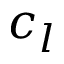Convert formula to latex. <formula><loc_0><loc_0><loc_500><loc_500>c _ { l }</formula> 